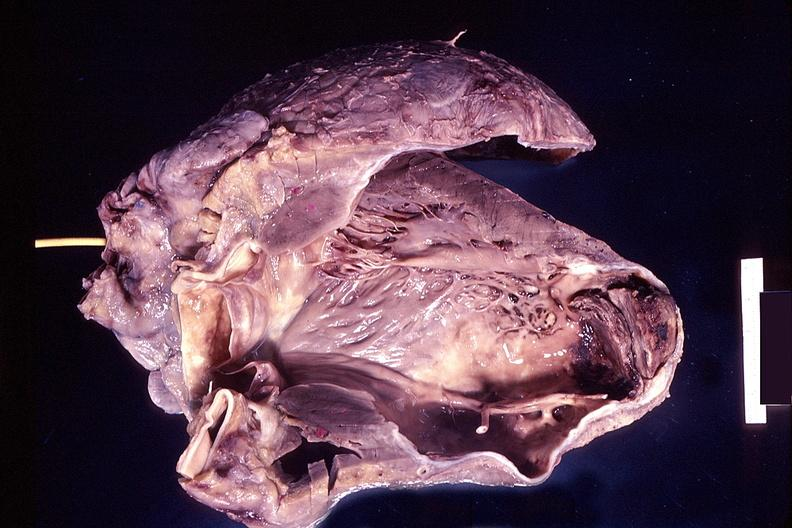where is this?
Answer the question using a single word or phrase. Heart 